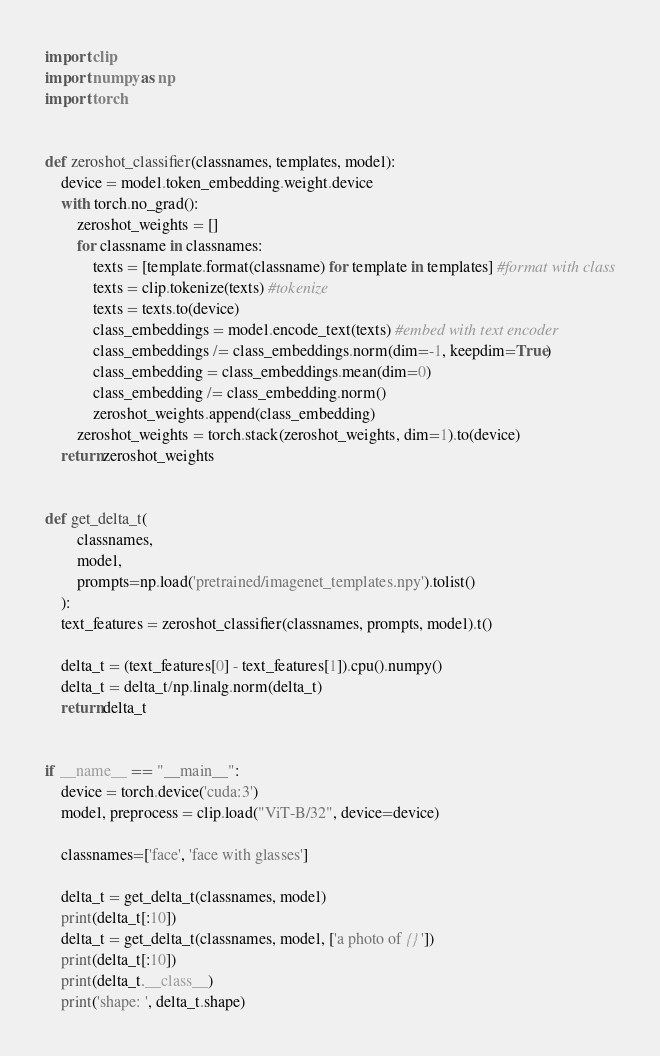<code> <loc_0><loc_0><loc_500><loc_500><_Python_>import clip
import numpy as np
import torch


def zeroshot_classifier(classnames, templates, model):
    device = model.token_embedding.weight.device
    with torch.no_grad():
        zeroshot_weights = []
        for classname in classnames:
            texts = [template.format(classname) for template in templates] #format with class
            texts = clip.tokenize(texts) #tokenize
            texts = texts.to(device)
            class_embeddings = model.encode_text(texts) #embed with text encoder
            class_embeddings /= class_embeddings.norm(dim=-1, keepdim=True)
            class_embedding = class_embeddings.mean(dim=0)
            class_embedding /= class_embedding.norm()
            zeroshot_weights.append(class_embedding)
        zeroshot_weights = torch.stack(zeroshot_weights, dim=1).to(device)
    return zeroshot_weights


def get_delta_t(
        classnames, 
        model, 
        prompts=np.load('pretrained/imagenet_templates.npy').tolist()
    ):
    text_features = zeroshot_classifier(classnames, prompts, model).t()

    delta_t = (text_features[0] - text_features[1]).cpu().numpy()
    delta_t = delta_t/np.linalg.norm(delta_t)
    return delta_t


if __name__ == "__main__":
    device = torch.device('cuda:3')
    model, preprocess = clip.load("ViT-B/32", device=device)
    
    classnames=['face', 'face with glasses']

    delta_t = get_delta_t(classnames, model)
    print(delta_t[:10])
    delta_t = get_delta_t(classnames, model, ['a photo of {}'])
    print(delta_t[:10])
    print(delta_t.__class__)
    print('shape: ', delta_t.shape)
</code> 